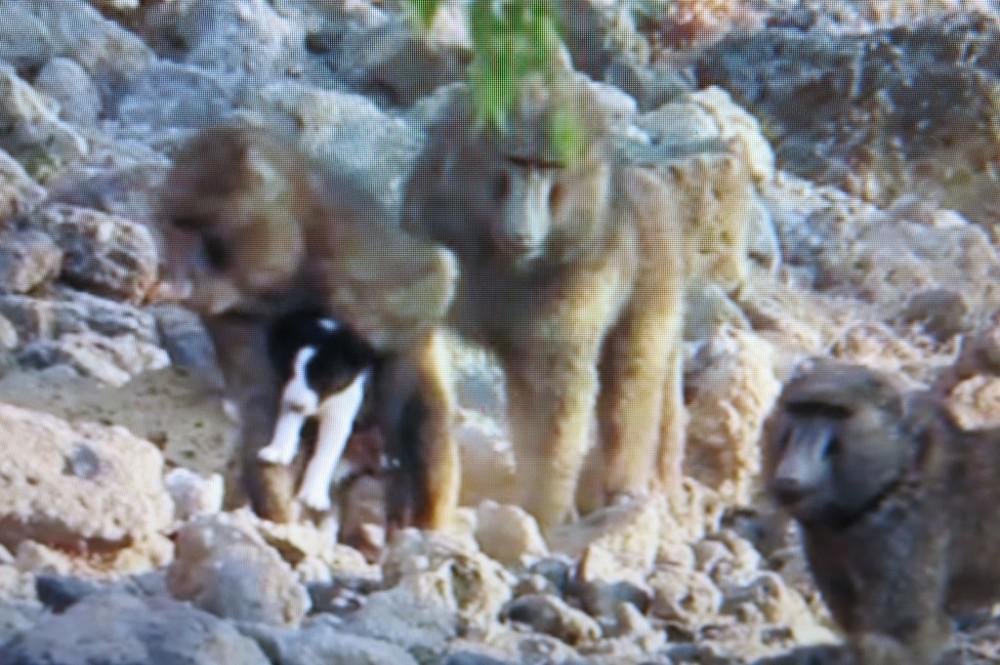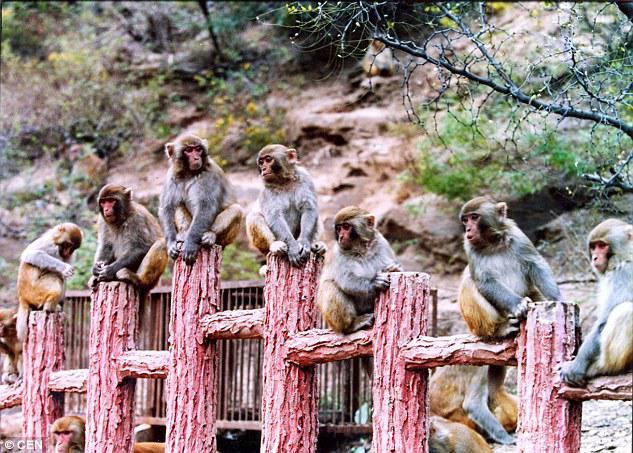The first image is the image on the left, the second image is the image on the right. Given the left and right images, does the statement "There are at most 3 baboons in the left image." hold true? Answer yes or no. Yes. The first image is the image on the left, the second image is the image on the right. Analyze the images presented: Is the assertion "Baboons are walking along a dirt path flanked by bushes and trees in one image." valid? Answer yes or no. No. 